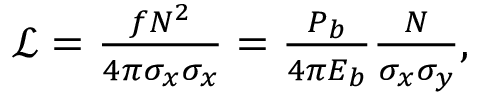Convert formula to latex. <formula><loc_0><loc_0><loc_500><loc_500>\begin{array} { r } { \mathcal { L } = \frac { f N ^ { 2 } } { 4 \pi \sigma _ { x } \sigma _ { x } } = \frac { P _ { b } } { 4 \pi E _ { b } } \frac { N } { \sigma _ { x } \sigma _ { y } } , } \end{array}</formula> 